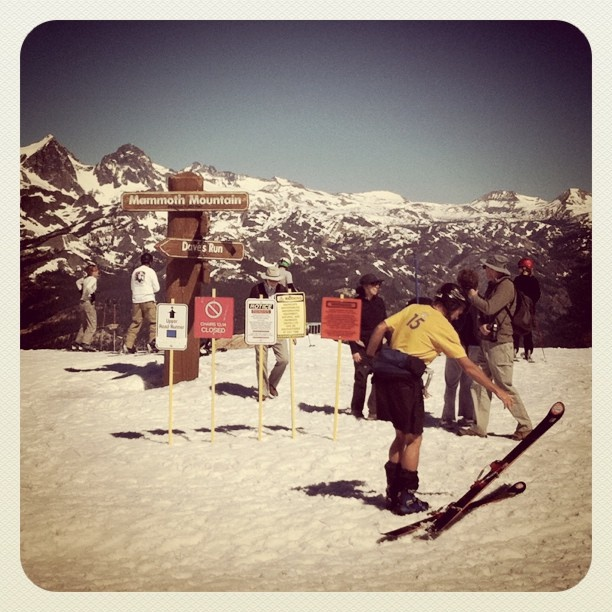Describe the objects in this image and their specific colors. I can see people in ivory, black, tan, maroon, and brown tones, people in ivory, maroon, brown, gray, and black tones, people in ivory, black, maroon, and brown tones, people in ivory, maroon, black, and brown tones, and people in ivory, beige, gray, maroon, and tan tones in this image. 